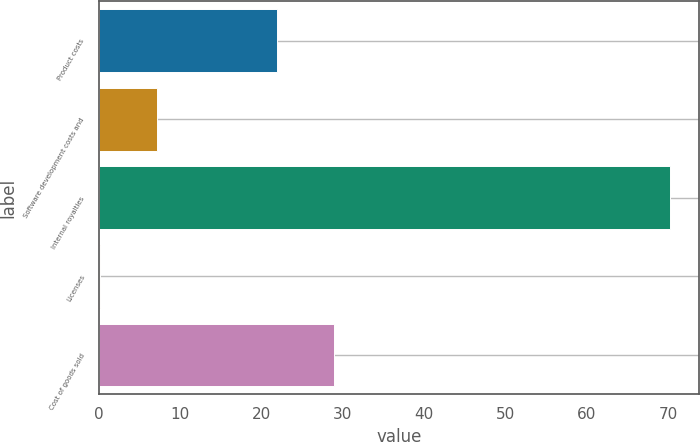Convert chart. <chart><loc_0><loc_0><loc_500><loc_500><bar_chart><fcel>Product costs<fcel>Software development costs and<fcel>Internal royalties<fcel>Licenses<fcel>Cost of goods sold<nl><fcel>21.9<fcel>7.12<fcel>70.3<fcel>0.1<fcel>28.92<nl></chart> 